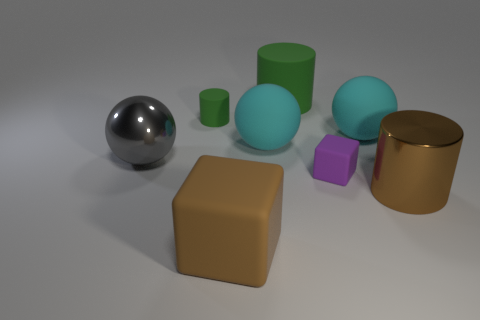How many large cyan rubber objects are the same shape as the large gray shiny thing?
Provide a succinct answer. 2. Do the big matte block and the metallic cylinder have the same color?
Provide a short and direct response. Yes. There is a small cylinder that is behind the brown object on the left side of the shiny thing on the right side of the gray metallic sphere; what is its material?
Provide a succinct answer. Rubber. There is a big gray object; are there any cyan rubber balls behind it?
Keep it short and to the point. Yes. There is another object that is the same size as the purple thing; what is its shape?
Give a very brief answer. Cylinder. Is the material of the purple block the same as the big green thing?
Provide a short and direct response. Yes. What number of metallic things are either cyan objects or small purple cubes?
Ensure brevity in your answer.  0. There is a metal thing that is the same color as the large block; what shape is it?
Your answer should be compact. Cylinder. There is a matte object to the left of the big brown matte thing; is its color the same as the large rubber cylinder?
Offer a terse response. Yes. There is a small rubber object that is on the right side of the rubber block in front of the big brown metallic object; what is its shape?
Keep it short and to the point. Cube. 